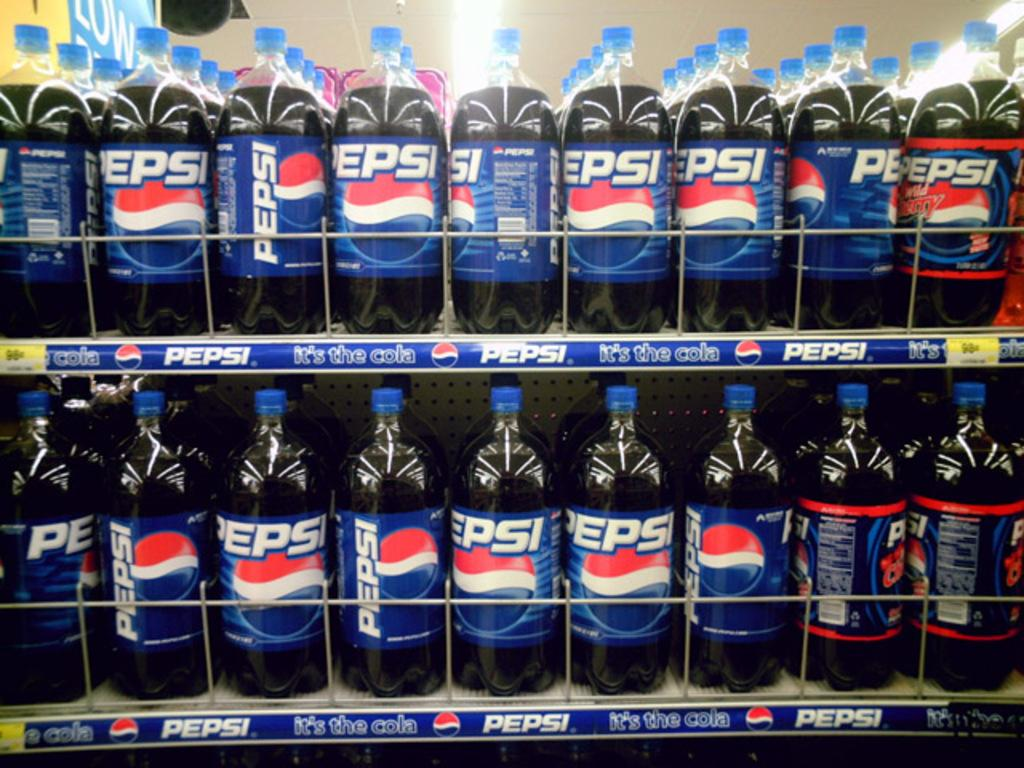<image>
Summarize the visual content of the image. A store displays shelves of Pepsi in 2 liter bottles. 